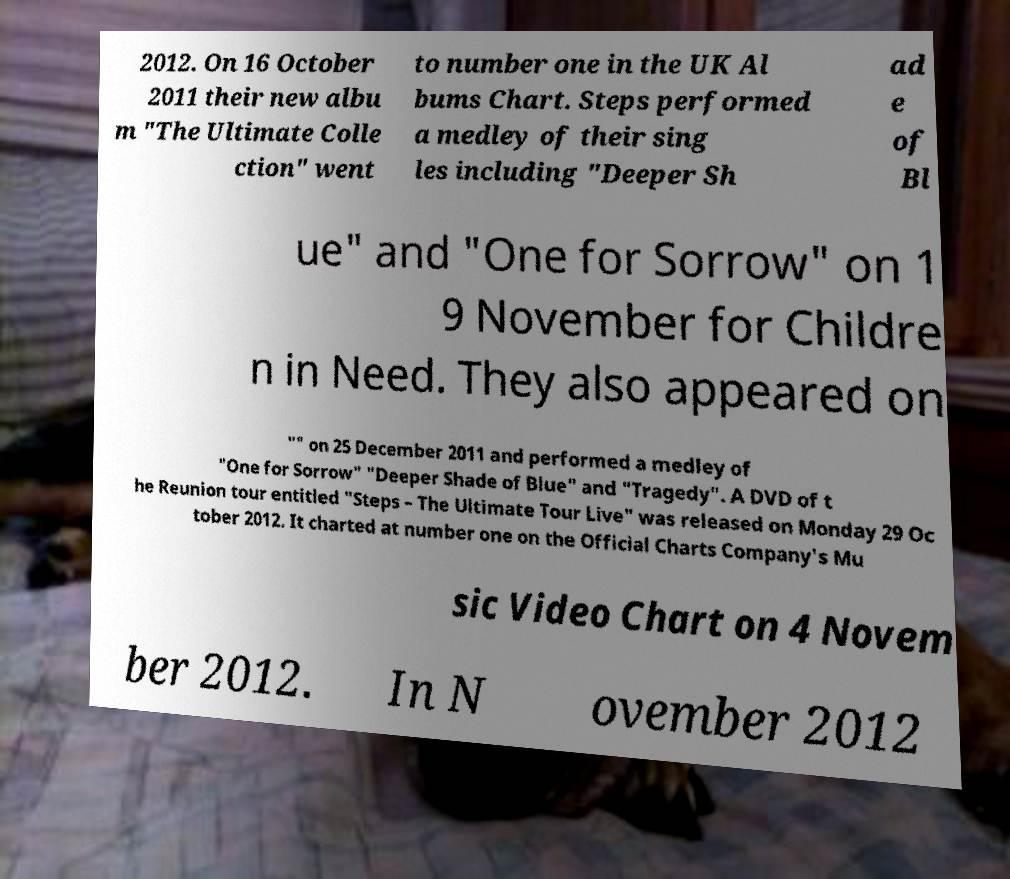There's text embedded in this image that I need extracted. Can you transcribe it verbatim? 2012. On 16 October 2011 their new albu m "The Ultimate Colle ction" went to number one in the UK Al bums Chart. Steps performed a medley of their sing les including "Deeper Sh ad e of Bl ue" and "One for Sorrow" on 1 9 November for Childre n in Need. They also appeared on "" on 25 December 2011 and performed a medley of "One for Sorrow" "Deeper Shade of Blue" and "Tragedy". A DVD of t he Reunion tour entitled "Steps – The Ultimate Tour Live" was released on Monday 29 Oc tober 2012. It charted at number one on the Official Charts Company's Mu sic Video Chart on 4 Novem ber 2012. In N ovember 2012 